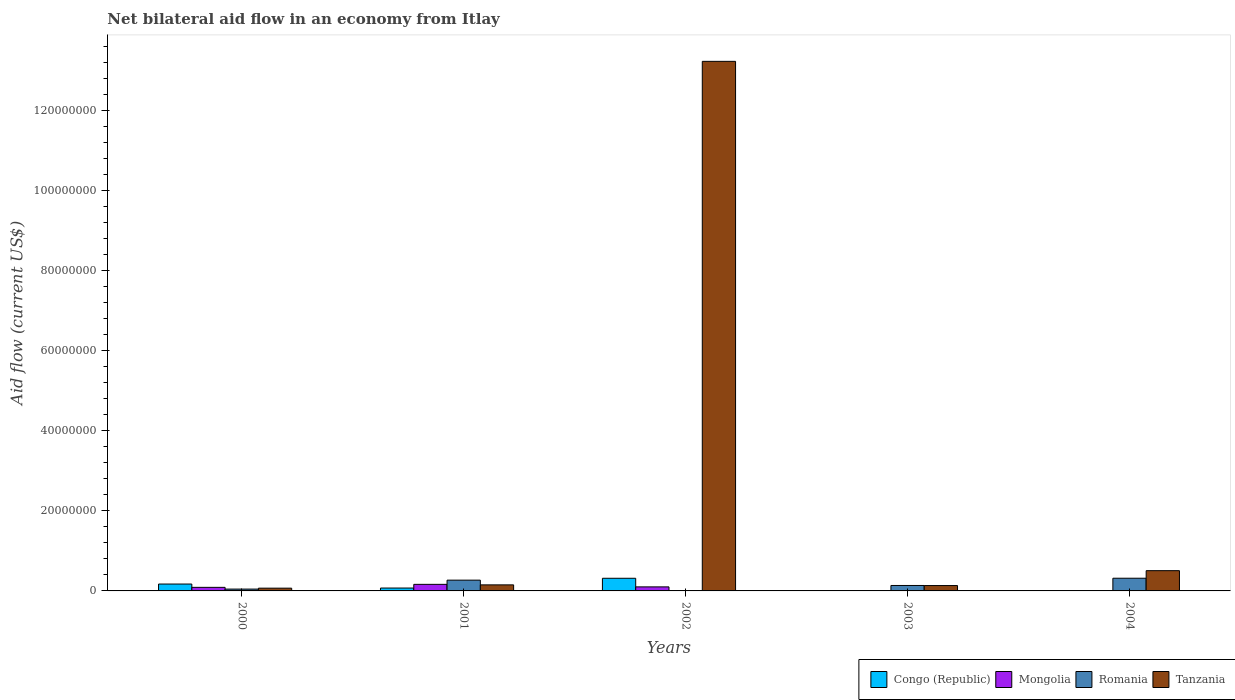How many different coloured bars are there?
Keep it short and to the point. 4. Are the number of bars on each tick of the X-axis equal?
Your answer should be very brief. No. How many bars are there on the 1st tick from the left?
Your response must be concise. 4. In how many cases, is the number of bars for a given year not equal to the number of legend labels?
Ensure brevity in your answer.  2. Across all years, what is the maximum net bilateral aid flow in Romania?
Offer a very short reply. 3.17e+06. Across all years, what is the minimum net bilateral aid flow in Tanzania?
Your response must be concise. 6.90e+05. In which year was the net bilateral aid flow in Tanzania maximum?
Your response must be concise. 2002. What is the total net bilateral aid flow in Congo (Republic) in the graph?
Ensure brevity in your answer.  5.60e+06. What is the difference between the net bilateral aid flow in Mongolia in 2001 and that in 2004?
Provide a short and direct response. 1.63e+06. What is the difference between the net bilateral aid flow in Mongolia in 2000 and the net bilateral aid flow in Congo (Republic) in 2004?
Your answer should be compact. 8.90e+05. What is the average net bilateral aid flow in Tanzania per year?
Provide a short and direct response. 2.82e+07. In the year 2001, what is the difference between the net bilateral aid flow in Tanzania and net bilateral aid flow in Romania?
Provide a short and direct response. -1.18e+06. In how many years, is the net bilateral aid flow in Romania greater than 32000000 US$?
Give a very brief answer. 0. What is the ratio of the net bilateral aid flow in Romania in 2000 to that in 2004?
Provide a succinct answer. 0.15. Is the net bilateral aid flow in Tanzania in 2000 less than that in 2002?
Your answer should be compact. Yes. Is the difference between the net bilateral aid flow in Tanzania in 2002 and 2003 greater than the difference between the net bilateral aid flow in Romania in 2002 and 2003?
Give a very brief answer. Yes. What is the difference between the highest and the second highest net bilateral aid flow in Congo (Republic)?
Provide a succinct answer. 1.44e+06. What is the difference between the highest and the lowest net bilateral aid flow in Congo (Republic)?
Your answer should be very brief. 3.16e+06. Is the sum of the net bilateral aid flow in Mongolia in 2001 and 2004 greater than the maximum net bilateral aid flow in Congo (Republic) across all years?
Your response must be concise. No. Is it the case that in every year, the sum of the net bilateral aid flow in Mongolia and net bilateral aid flow in Congo (Republic) is greater than the sum of net bilateral aid flow in Tanzania and net bilateral aid flow in Romania?
Provide a short and direct response. No. Is it the case that in every year, the sum of the net bilateral aid flow in Congo (Republic) and net bilateral aid flow in Mongolia is greater than the net bilateral aid flow in Tanzania?
Your response must be concise. No. Are all the bars in the graph horizontal?
Give a very brief answer. No. How many years are there in the graph?
Make the answer very short. 5. Does the graph contain grids?
Keep it short and to the point. No. How many legend labels are there?
Your answer should be very brief. 4. What is the title of the graph?
Your answer should be very brief. Net bilateral aid flow in an economy from Itlay. Does "Costa Rica" appear as one of the legend labels in the graph?
Your answer should be compact. No. What is the label or title of the X-axis?
Give a very brief answer. Years. What is the label or title of the Y-axis?
Keep it short and to the point. Aid flow (current US$). What is the Aid flow (current US$) in Congo (Republic) in 2000?
Your response must be concise. 1.72e+06. What is the Aid flow (current US$) in Mongolia in 2000?
Offer a very short reply. 8.90e+05. What is the Aid flow (current US$) in Romania in 2000?
Ensure brevity in your answer.  4.60e+05. What is the Aid flow (current US$) of Tanzania in 2000?
Your answer should be compact. 6.90e+05. What is the Aid flow (current US$) of Congo (Republic) in 2001?
Your answer should be compact. 7.20e+05. What is the Aid flow (current US$) in Mongolia in 2001?
Make the answer very short. 1.64e+06. What is the Aid flow (current US$) in Romania in 2001?
Provide a short and direct response. 2.69e+06. What is the Aid flow (current US$) in Tanzania in 2001?
Your response must be concise. 1.51e+06. What is the Aid flow (current US$) in Congo (Republic) in 2002?
Your answer should be compact. 3.16e+06. What is the Aid flow (current US$) of Mongolia in 2002?
Ensure brevity in your answer.  1.01e+06. What is the Aid flow (current US$) in Tanzania in 2002?
Give a very brief answer. 1.32e+08. What is the Aid flow (current US$) of Mongolia in 2003?
Keep it short and to the point. 2.00e+04. What is the Aid flow (current US$) in Romania in 2003?
Ensure brevity in your answer.  1.36e+06. What is the Aid flow (current US$) of Tanzania in 2003?
Your answer should be compact. 1.34e+06. What is the Aid flow (current US$) in Mongolia in 2004?
Offer a very short reply. 10000. What is the Aid flow (current US$) in Romania in 2004?
Keep it short and to the point. 3.17e+06. What is the Aid flow (current US$) of Tanzania in 2004?
Offer a very short reply. 5.06e+06. Across all years, what is the maximum Aid flow (current US$) of Congo (Republic)?
Ensure brevity in your answer.  3.16e+06. Across all years, what is the maximum Aid flow (current US$) of Mongolia?
Your answer should be very brief. 1.64e+06. Across all years, what is the maximum Aid flow (current US$) of Romania?
Give a very brief answer. 3.17e+06. Across all years, what is the maximum Aid flow (current US$) of Tanzania?
Ensure brevity in your answer.  1.32e+08. Across all years, what is the minimum Aid flow (current US$) of Congo (Republic)?
Provide a short and direct response. 0. Across all years, what is the minimum Aid flow (current US$) in Romania?
Offer a terse response. 10000. Across all years, what is the minimum Aid flow (current US$) in Tanzania?
Offer a very short reply. 6.90e+05. What is the total Aid flow (current US$) in Congo (Republic) in the graph?
Your response must be concise. 5.60e+06. What is the total Aid flow (current US$) of Mongolia in the graph?
Provide a succinct answer. 3.57e+06. What is the total Aid flow (current US$) in Romania in the graph?
Your answer should be compact. 7.69e+06. What is the total Aid flow (current US$) in Tanzania in the graph?
Offer a very short reply. 1.41e+08. What is the difference between the Aid flow (current US$) of Mongolia in 2000 and that in 2001?
Make the answer very short. -7.50e+05. What is the difference between the Aid flow (current US$) in Romania in 2000 and that in 2001?
Provide a short and direct response. -2.23e+06. What is the difference between the Aid flow (current US$) of Tanzania in 2000 and that in 2001?
Make the answer very short. -8.20e+05. What is the difference between the Aid flow (current US$) in Congo (Republic) in 2000 and that in 2002?
Ensure brevity in your answer.  -1.44e+06. What is the difference between the Aid flow (current US$) of Mongolia in 2000 and that in 2002?
Ensure brevity in your answer.  -1.20e+05. What is the difference between the Aid flow (current US$) in Tanzania in 2000 and that in 2002?
Make the answer very short. -1.32e+08. What is the difference between the Aid flow (current US$) of Mongolia in 2000 and that in 2003?
Offer a very short reply. 8.70e+05. What is the difference between the Aid flow (current US$) in Romania in 2000 and that in 2003?
Your answer should be compact. -9.00e+05. What is the difference between the Aid flow (current US$) of Tanzania in 2000 and that in 2003?
Give a very brief answer. -6.50e+05. What is the difference between the Aid flow (current US$) in Mongolia in 2000 and that in 2004?
Give a very brief answer. 8.80e+05. What is the difference between the Aid flow (current US$) of Romania in 2000 and that in 2004?
Your answer should be very brief. -2.71e+06. What is the difference between the Aid flow (current US$) in Tanzania in 2000 and that in 2004?
Your answer should be very brief. -4.37e+06. What is the difference between the Aid flow (current US$) in Congo (Republic) in 2001 and that in 2002?
Provide a succinct answer. -2.44e+06. What is the difference between the Aid flow (current US$) of Mongolia in 2001 and that in 2002?
Offer a terse response. 6.30e+05. What is the difference between the Aid flow (current US$) in Romania in 2001 and that in 2002?
Provide a short and direct response. 2.68e+06. What is the difference between the Aid flow (current US$) in Tanzania in 2001 and that in 2002?
Provide a succinct answer. -1.31e+08. What is the difference between the Aid flow (current US$) of Mongolia in 2001 and that in 2003?
Make the answer very short. 1.62e+06. What is the difference between the Aid flow (current US$) in Romania in 2001 and that in 2003?
Ensure brevity in your answer.  1.33e+06. What is the difference between the Aid flow (current US$) of Mongolia in 2001 and that in 2004?
Your answer should be compact. 1.63e+06. What is the difference between the Aid flow (current US$) of Romania in 2001 and that in 2004?
Offer a terse response. -4.80e+05. What is the difference between the Aid flow (current US$) in Tanzania in 2001 and that in 2004?
Your answer should be compact. -3.55e+06. What is the difference between the Aid flow (current US$) of Mongolia in 2002 and that in 2003?
Your answer should be compact. 9.90e+05. What is the difference between the Aid flow (current US$) in Romania in 2002 and that in 2003?
Keep it short and to the point. -1.35e+06. What is the difference between the Aid flow (current US$) in Tanzania in 2002 and that in 2003?
Your response must be concise. 1.31e+08. What is the difference between the Aid flow (current US$) in Mongolia in 2002 and that in 2004?
Give a very brief answer. 1.00e+06. What is the difference between the Aid flow (current US$) of Romania in 2002 and that in 2004?
Offer a terse response. -3.16e+06. What is the difference between the Aid flow (current US$) in Tanzania in 2002 and that in 2004?
Provide a succinct answer. 1.27e+08. What is the difference between the Aid flow (current US$) in Romania in 2003 and that in 2004?
Provide a short and direct response. -1.81e+06. What is the difference between the Aid flow (current US$) of Tanzania in 2003 and that in 2004?
Ensure brevity in your answer.  -3.72e+06. What is the difference between the Aid flow (current US$) in Congo (Republic) in 2000 and the Aid flow (current US$) in Romania in 2001?
Give a very brief answer. -9.70e+05. What is the difference between the Aid flow (current US$) in Mongolia in 2000 and the Aid flow (current US$) in Romania in 2001?
Give a very brief answer. -1.80e+06. What is the difference between the Aid flow (current US$) in Mongolia in 2000 and the Aid flow (current US$) in Tanzania in 2001?
Provide a short and direct response. -6.20e+05. What is the difference between the Aid flow (current US$) in Romania in 2000 and the Aid flow (current US$) in Tanzania in 2001?
Provide a short and direct response. -1.05e+06. What is the difference between the Aid flow (current US$) of Congo (Republic) in 2000 and the Aid flow (current US$) of Mongolia in 2002?
Make the answer very short. 7.10e+05. What is the difference between the Aid flow (current US$) in Congo (Republic) in 2000 and the Aid flow (current US$) in Romania in 2002?
Make the answer very short. 1.71e+06. What is the difference between the Aid flow (current US$) of Congo (Republic) in 2000 and the Aid flow (current US$) of Tanzania in 2002?
Offer a terse response. -1.31e+08. What is the difference between the Aid flow (current US$) in Mongolia in 2000 and the Aid flow (current US$) in Romania in 2002?
Provide a short and direct response. 8.80e+05. What is the difference between the Aid flow (current US$) in Mongolia in 2000 and the Aid flow (current US$) in Tanzania in 2002?
Offer a terse response. -1.31e+08. What is the difference between the Aid flow (current US$) in Romania in 2000 and the Aid flow (current US$) in Tanzania in 2002?
Offer a very short reply. -1.32e+08. What is the difference between the Aid flow (current US$) in Congo (Republic) in 2000 and the Aid flow (current US$) in Mongolia in 2003?
Your answer should be very brief. 1.70e+06. What is the difference between the Aid flow (current US$) in Mongolia in 2000 and the Aid flow (current US$) in Romania in 2003?
Provide a short and direct response. -4.70e+05. What is the difference between the Aid flow (current US$) in Mongolia in 2000 and the Aid flow (current US$) in Tanzania in 2003?
Offer a very short reply. -4.50e+05. What is the difference between the Aid flow (current US$) in Romania in 2000 and the Aid flow (current US$) in Tanzania in 2003?
Make the answer very short. -8.80e+05. What is the difference between the Aid flow (current US$) of Congo (Republic) in 2000 and the Aid flow (current US$) of Mongolia in 2004?
Offer a terse response. 1.71e+06. What is the difference between the Aid flow (current US$) in Congo (Republic) in 2000 and the Aid flow (current US$) in Romania in 2004?
Give a very brief answer. -1.45e+06. What is the difference between the Aid flow (current US$) in Congo (Republic) in 2000 and the Aid flow (current US$) in Tanzania in 2004?
Offer a very short reply. -3.34e+06. What is the difference between the Aid flow (current US$) in Mongolia in 2000 and the Aid flow (current US$) in Romania in 2004?
Keep it short and to the point. -2.28e+06. What is the difference between the Aid flow (current US$) of Mongolia in 2000 and the Aid flow (current US$) of Tanzania in 2004?
Your answer should be compact. -4.17e+06. What is the difference between the Aid flow (current US$) in Romania in 2000 and the Aid flow (current US$) in Tanzania in 2004?
Provide a short and direct response. -4.60e+06. What is the difference between the Aid flow (current US$) of Congo (Republic) in 2001 and the Aid flow (current US$) of Mongolia in 2002?
Provide a short and direct response. -2.90e+05. What is the difference between the Aid flow (current US$) of Congo (Republic) in 2001 and the Aid flow (current US$) of Romania in 2002?
Keep it short and to the point. 7.10e+05. What is the difference between the Aid flow (current US$) of Congo (Republic) in 2001 and the Aid flow (current US$) of Tanzania in 2002?
Provide a succinct answer. -1.32e+08. What is the difference between the Aid flow (current US$) of Mongolia in 2001 and the Aid flow (current US$) of Romania in 2002?
Offer a terse response. 1.63e+06. What is the difference between the Aid flow (current US$) of Mongolia in 2001 and the Aid flow (current US$) of Tanzania in 2002?
Keep it short and to the point. -1.31e+08. What is the difference between the Aid flow (current US$) of Romania in 2001 and the Aid flow (current US$) of Tanzania in 2002?
Your answer should be very brief. -1.30e+08. What is the difference between the Aid flow (current US$) of Congo (Republic) in 2001 and the Aid flow (current US$) of Romania in 2003?
Ensure brevity in your answer.  -6.40e+05. What is the difference between the Aid flow (current US$) of Congo (Republic) in 2001 and the Aid flow (current US$) of Tanzania in 2003?
Offer a terse response. -6.20e+05. What is the difference between the Aid flow (current US$) of Mongolia in 2001 and the Aid flow (current US$) of Tanzania in 2003?
Ensure brevity in your answer.  3.00e+05. What is the difference between the Aid flow (current US$) in Romania in 2001 and the Aid flow (current US$) in Tanzania in 2003?
Provide a short and direct response. 1.35e+06. What is the difference between the Aid flow (current US$) in Congo (Republic) in 2001 and the Aid flow (current US$) in Mongolia in 2004?
Provide a succinct answer. 7.10e+05. What is the difference between the Aid flow (current US$) in Congo (Republic) in 2001 and the Aid flow (current US$) in Romania in 2004?
Offer a very short reply. -2.45e+06. What is the difference between the Aid flow (current US$) in Congo (Republic) in 2001 and the Aid flow (current US$) in Tanzania in 2004?
Give a very brief answer. -4.34e+06. What is the difference between the Aid flow (current US$) in Mongolia in 2001 and the Aid flow (current US$) in Romania in 2004?
Ensure brevity in your answer.  -1.53e+06. What is the difference between the Aid flow (current US$) of Mongolia in 2001 and the Aid flow (current US$) of Tanzania in 2004?
Offer a terse response. -3.42e+06. What is the difference between the Aid flow (current US$) of Romania in 2001 and the Aid flow (current US$) of Tanzania in 2004?
Your answer should be very brief. -2.37e+06. What is the difference between the Aid flow (current US$) of Congo (Republic) in 2002 and the Aid flow (current US$) of Mongolia in 2003?
Give a very brief answer. 3.14e+06. What is the difference between the Aid flow (current US$) of Congo (Republic) in 2002 and the Aid flow (current US$) of Romania in 2003?
Offer a very short reply. 1.80e+06. What is the difference between the Aid flow (current US$) of Congo (Republic) in 2002 and the Aid flow (current US$) of Tanzania in 2003?
Offer a terse response. 1.82e+06. What is the difference between the Aid flow (current US$) of Mongolia in 2002 and the Aid flow (current US$) of Romania in 2003?
Your response must be concise. -3.50e+05. What is the difference between the Aid flow (current US$) in Mongolia in 2002 and the Aid flow (current US$) in Tanzania in 2003?
Your answer should be very brief. -3.30e+05. What is the difference between the Aid flow (current US$) of Romania in 2002 and the Aid flow (current US$) of Tanzania in 2003?
Make the answer very short. -1.33e+06. What is the difference between the Aid flow (current US$) of Congo (Republic) in 2002 and the Aid flow (current US$) of Mongolia in 2004?
Offer a very short reply. 3.15e+06. What is the difference between the Aid flow (current US$) in Congo (Republic) in 2002 and the Aid flow (current US$) in Romania in 2004?
Offer a terse response. -10000. What is the difference between the Aid flow (current US$) in Congo (Republic) in 2002 and the Aid flow (current US$) in Tanzania in 2004?
Give a very brief answer. -1.90e+06. What is the difference between the Aid flow (current US$) of Mongolia in 2002 and the Aid flow (current US$) of Romania in 2004?
Make the answer very short. -2.16e+06. What is the difference between the Aid flow (current US$) in Mongolia in 2002 and the Aid flow (current US$) in Tanzania in 2004?
Keep it short and to the point. -4.05e+06. What is the difference between the Aid flow (current US$) of Romania in 2002 and the Aid flow (current US$) of Tanzania in 2004?
Provide a succinct answer. -5.05e+06. What is the difference between the Aid flow (current US$) in Mongolia in 2003 and the Aid flow (current US$) in Romania in 2004?
Offer a terse response. -3.15e+06. What is the difference between the Aid flow (current US$) of Mongolia in 2003 and the Aid flow (current US$) of Tanzania in 2004?
Keep it short and to the point. -5.04e+06. What is the difference between the Aid flow (current US$) of Romania in 2003 and the Aid flow (current US$) of Tanzania in 2004?
Make the answer very short. -3.70e+06. What is the average Aid flow (current US$) in Congo (Republic) per year?
Your answer should be compact. 1.12e+06. What is the average Aid flow (current US$) in Mongolia per year?
Ensure brevity in your answer.  7.14e+05. What is the average Aid flow (current US$) in Romania per year?
Offer a very short reply. 1.54e+06. What is the average Aid flow (current US$) in Tanzania per year?
Make the answer very short. 2.82e+07. In the year 2000, what is the difference between the Aid flow (current US$) in Congo (Republic) and Aid flow (current US$) in Mongolia?
Make the answer very short. 8.30e+05. In the year 2000, what is the difference between the Aid flow (current US$) in Congo (Republic) and Aid flow (current US$) in Romania?
Give a very brief answer. 1.26e+06. In the year 2000, what is the difference between the Aid flow (current US$) of Congo (Republic) and Aid flow (current US$) of Tanzania?
Ensure brevity in your answer.  1.03e+06. In the year 2000, what is the difference between the Aid flow (current US$) in Romania and Aid flow (current US$) in Tanzania?
Give a very brief answer. -2.30e+05. In the year 2001, what is the difference between the Aid flow (current US$) in Congo (Republic) and Aid flow (current US$) in Mongolia?
Your response must be concise. -9.20e+05. In the year 2001, what is the difference between the Aid flow (current US$) of Congo (Republic) and Aid flow (current US$) of Romania?
Provide a succinct answer. -1.97e+06. In the year 2001, what is the difference between the Aid flow (current US$) of Congo (Republic) and Aid flow (current US$) of Tanzania?
Your answer should be very brief. -7.90e+05. In the year 2001, what is the difference between the Aid flow (current US$) in Mongolia and Aid flow (current US$) in Romania?
Offer a very short reply. -1.05e+06. In the year 2001, what is the difference between the Aid flow (current US$) of Mongolia and Aid flow (current US$) of Tanzania?
Your response must be concise. 1.30e+05. In the year 2001, what is the difference between the Aid flow (current US$) of Romania and Aid flow (current US$) of Tanzania?
Your response must be concise. 1.18e+06. In the year 2002, what is the difference between the Aid flow (current US$) in Congo (Republic) and Aid flow (current US$) in Mongolia?
Keep it short and to the point. 2.15e+06. In the year 2002, what is the difference between the Aid flow (current US$) in Congo (Republic) and Aid flow (current US$) in Romania?
Make the answer very short. 3.15e+06. In the year 2002, what is the difference between the Aid flow (current US$) of Congo (Republic) and Aid flow (current US$) of Tanzania?
Give a very brief answer. -1.29e+08. In the year 2002, what is the difference between the Aid flow (current US$) of Mongolia and Aid flow (current US$) of Romania?
Your answer should be compact. 1.00e+06. In the year 2002, what is the difference between the Aid flow (current US$) of Mongolia and Aid flow (current US$) of Tanzania?
Make the answer very short. -1.31e+08. In the year 2002, what is the difference between the Aid flow (current US$) of Romania and Aid flow (current US$) of Tanzania?
Provide a short and direct response. -1.32e+08. In the year 2003, what is the difference between the Aid flow (current US$) of Mongolia and Aid flow (current US$) of Romania?
Your response must be concise. -1.34e+06. In the year 2003, what is the difference between the Aid flow (current US$) in Mongolia and Aid flow (current US$) in Tanzania?
Your answer should be compact. -1.32e+06. In the year 2003, what is the difference between the Aid flow (current US$) in Romania and Aid flow (current US$) in Tanzania?
Keep it short and to the point. 2.00e+04. In the year 2004, what is the difference between the Aid flow (current US$) in Mongolia and Aid flow (current US$) in Romania?
Your answer should be compact. -3.16e+06. In the year 2004, what is the difference between the Aid flow (current US$) of Mongolia and Aid flow (current US$) of Tanzania?
Your response must be concise. -5.05e+06. In the year 2004, what is the difference between the Aid flow (current US$) of Romania and Aid flow (current US$) of Tanzania?
Keep it short and to the point. -1.89e+06. What is the ratio of the Aid flow (current US$) of Congo (Republic) in 2000 to that in 2001?
Ensure brevity in your answer.  2.39. What is the ratio of the Aid flow (current US$) of Mongolia in 2000 to that in 2001?
Your answer should be very brief. 0.54. What is the ratio of the Aid flow (current US$) of Romania in 2000 to that in 2001?
Provide a short and direct response. 0.17. What is the ratio of the Aid flow (current US$) of Tanzania in 2000 to that in 2001?
Offer a very short reply. 0.46. What is the ratio of the Aid flow (current US$) in Congo (Republic) in 2000 to that in 2002?
Offer a very short reply. 0.54. What is the ratio of the Aid flow (current US$) in Mongolia in 2000 to that in 2002?
Your answer should be very brief. 0.88. What is the ratio of the Aid flow (current US$) of Tanzania in 2000 to that in 2002?
Provide a short and direct response. 0.01. What is the ratio of the Aid flow (current US$) of Mongolia in 2000 to that in 2003?
Make the answer very short. 44.5. What is the ratio of the Aid flow (current US$) in Romania in 2000 to that in 2003?
Keep it short and to the point. 0.34. What is the ratio of the Aid flow (current US$) in Tanzania in 2000 to that in 2003?
Your answer should be very brief. 0.51. What is the ratio of the Aid flow (current US$) of Mongolia in 2000 to that in 2004?
Your response must be concise. 89. What is the ratio of the Aid flow (current US$) of Romania in 2000 to that in 2004?
Give a very brief answer. 0.15. What is the ratio of the Aid flow (current US$) of Tanzania in 2000 to that in 2004?
Keep it short and to the point. 0.14. What is the ratio of the Aid flow (current US$) of Congo (Republic) in 2001 to that in 2002?
Give a very brief answer. 0.23. What is the ratio of the Aid flow (current US$) of Mongolia in 2001 to that in 2002?
Provide a succinct answer. 1.62. What is the ratio of the Aid flow (current US$) in Romania in 2001 to that in 2002?
Keep it short and to the point. 269. What is the ratio of the Aid flow (current US$) in Tanzania in 2001 to that in 2002?
Provide a short and direct response. 0.01. What is the ratio of the Aid flow (current US$) of Romania in 2001 to that in 2003?
Your answer should be very brief. 1.98. What is the ratio of the Aid flow (current US$) of Tanzania in 2001 to that in 2003?
Offer a very short reply. 1.13. What is the ratio of the Aid flow (current US$) of Mongolia in 2001 to that in 2004?
Your answer should be very brief. 164. What is the ratio of the Aid flow (current US$) of Romania in 2001 to that in 2004?
Your answer should be very brief. 0.85. What is the ratio of the Aid flow (current US$) in Tanzania in 2001 to that in 2004?
Your response must be concise. 0.3. What is the ratio of the Aid flow (current US$) of Mongolia in 2002 to that in 2003?
Offer a very short reply. 50.5. What is the ratio of the Aid flow (current US$) of Romania in 2002 to that in 2003?
Ensure brevity in your answer.  0.01. What is the ratio of the Aid flow (current US$) in Tanzania in 2002 to that in 2003?
Provide a succinct answer. 98.69. What is the ratio of the Aid flow (current US$) in Mongolia in 2002 to that in 2004?
Provide a succinct answer. 101. What is the ratio of the Aid flow (current US$) of Romania in 2002 to that in 2004?
Give a very brief answer. 0. What is the ratio of the Aid flow (current US$) in Tanzania in 2002 to that in 2004?
Your response must be concise. 26.14. What is the ratio of the Aid flow (current US$) of Romania in 2003 to that in 2004?
Provide a short and direct response. 0.43. What is the ratio of the Aid flow (current US$) of Tanzania in 2003 to that in 2004?
Your answer should be compact. 0.26. What is the difference between the highest and the second highest Aid flow (current US$) of Congo (Republic)?
Offer a terse response. 1.44e+06. What is the difference between the highest and the second highest Aid flow (current US$) in Mongolia?
Your answer should be very brief. 6.30e+05. What is the difference between the highest and the second highest Aid flow (current US$) of Tanzania?
Provide a succinct answer. 1.27e+08. What is the difference between the highest and the lowest Aid flow (current US$) of Congo (Republic)?
Offer a terse response. 3.16e+06. What is the difference between the highest and the lowest Aid flow (current US$) in Mongolia?
Make the answer very short. 1.63e+06. What is the difference between the highest and the lowest Aid flow (current US$) in Romania?
Keep it short and to the point. 3.16e+06. What is the difference between the highest and the lowest Aid flow (current US$) of Tanzania?
Offer a terse response. 1.32e+08. 